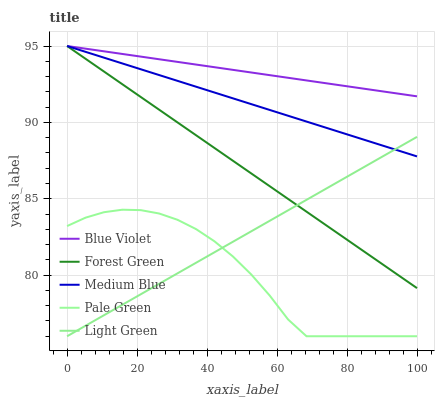Does Pale Green have the minimum area under the curve?
Answer yes or no. Yes. Does Blue Violet have the maximum area under the curve?
Answer yes or no. Yes. Does Medium Blue have the minimum area under the curve?
Answer yes or no. No. Does Medium Blue have the maximum area under the curve?
Answer yes or no. No. Is Forest Green the smoothest?
Answer yes or no. Yes. Is Pale Green the roughest?
Answer yes or no. Yes. Is Medium Blue the smoothest?
Answer yes or no. No. Is Medium Blue the roughest?
Answer yes or no. No. Does Pale Green have the lowest value?
Answer yes or no. Yes. Does Medium Blue have the lowest value?
Answer yes or no. No. Does Blue Violet have the highest value?
Answer yes or no. Yes. Does Pale Green have the highest value?
Answer yes or no. No. Is Pale Green less than Blue Violet?
Answer yes or no. Yes. Is Blue Violet greater than Light Green?
Answer yes or no. Yes. Does Light Green intersect Pale Green?
Answer yes or no. Yes. Is Light Green less than Pale Green?
Answer yes or no. No. Is Light Green greater than Pale Green?
Answer yes or no. No. Does Pale Green intersect Blue Violet?
Answer yes or no. No. 